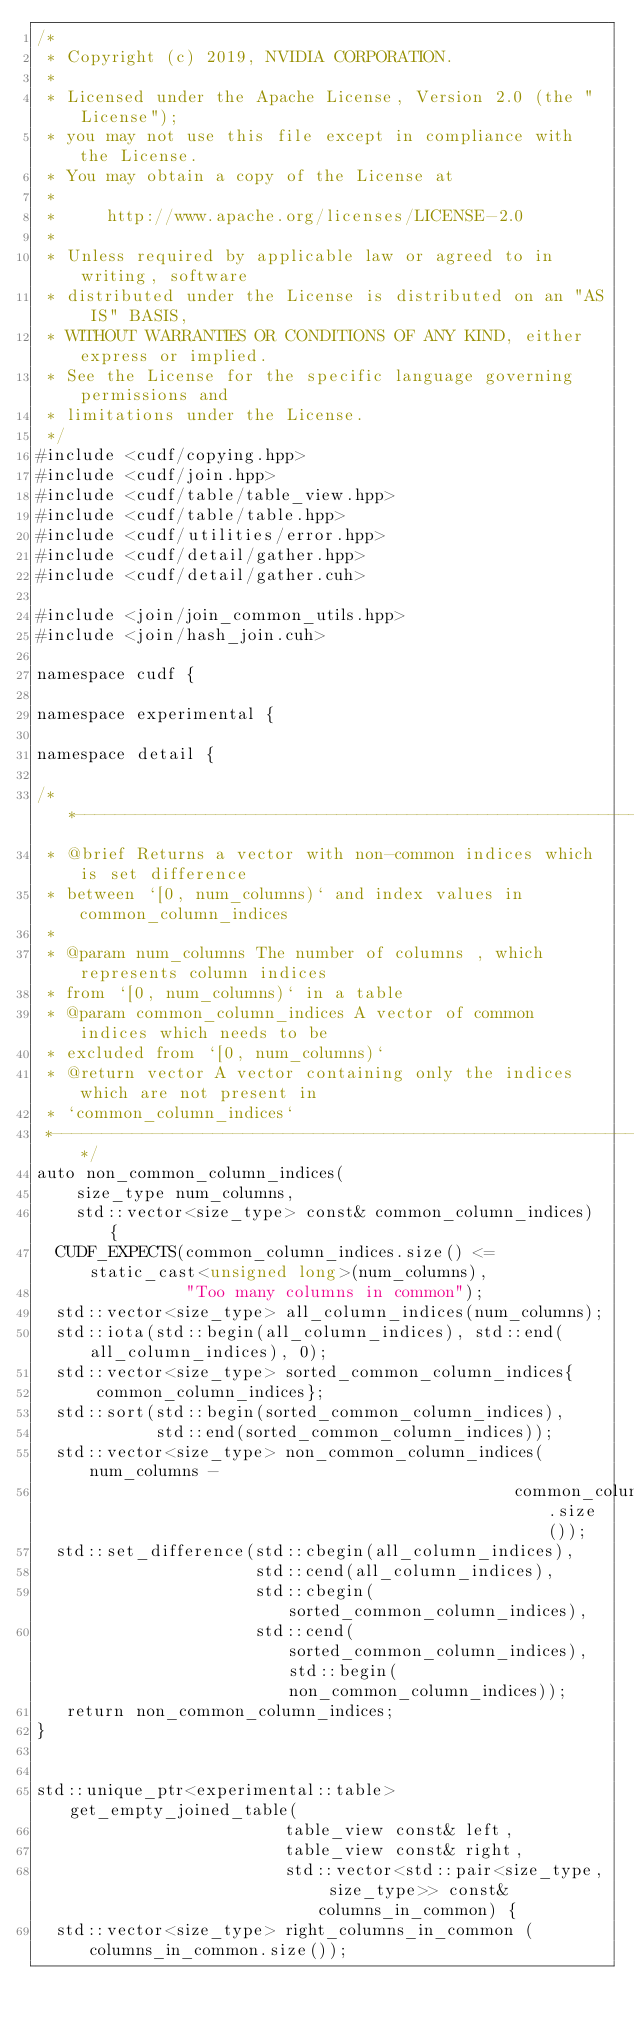<code> <loc_0><loc_0><loc_500><loc_500><_Cuda_>/*
 * Copyright (c) 2019, NVIDIA CORPORATION.
 *
 * Licensed under the Apache License, Version 2.0 (the "License");
 * you may not use this file except in compliance with the License.
 * You may obtain a copy of the License at
 *
 *     http://www.apache.org/licenses/LICENSE-2.0
 *
 * Unless required by applicable law or agreed to in writing, software
 * distributed under the License is distributed on an "AS IS" BASIS,
 * WITHOUT WARRANTIES OR CONDITIONS OF ANY KIND, either express or implied.
 * See the License for the specific language governing permissions and
 * limitations under the License.
 */
#include <cudf/copying.hpp>
#include <cudf/join.hpp>
#include <cudf/table/table_view.hpp>
#include <cudf/table/table.hpp>
#include <cudf/utilities/error.hpp>
#include <cudf/detail/gather.hpp>
#include <cudf/detail/gather.cuh>

#include <join/join_common_utils.hpp>
#include <join/hash_join.cuh>

namespace cudf {

namespace experimental {

namespace detail {

/**---------------------------------------------------------------------------*
 * @brief Returns a vector with non-common indices which is set difference
 * between `[0, num_columns)` and index values in common_column_indices
 *
 * @param num_columns The number of columns , which represents column indices
 * from `[0, num_columns)` in a table
 * @param common_column_indices A vector of common indices which needs to be
 * excluded from `[0, num_columns)`
 * @return vector A vector containing only the indices which are not present in
 * `common_column_indices`
 *---------------------------------------------------------------------------**/
auto non_common_column_indices(
    size_type num_columns,
    std::vector<size_type> const& common_column_indices) {
  CUDF_EXPECTS(common_column_indices.size() <= static_cast<unsigned long>(num_columns),
               "Too many columns in common");
  std::vector<size_type> all_column_indices(num_columns);
  std::iota(std::begin(all_column_indices), std::end(all_column_indices), 0);
  std::vector<size_type> sorted_common_column_indices{
      common_column_indices};
  std::sort(std::begin(sorted_common_column_indices),
            std::end(sorted_common_column_indices));
  std::vector<size_type> non_common_column_indices(num_columns -
                                                common_column_indices.size());
  std::set_difference(std::cbegin(all_column_indices),
                      std::cend(all_column_indices),
                      std::cbegin(sorted_common_column_indices),
                      std::cend(sorted_common_column_indices), std::begin(non_common_column_indices));
   return non_common_column_indices;
}


std::unique_ptr<experimental::table> get_empty_joined_table(
                         table_view const& left,
                         table_view const& right,
                         std::vector<std::pair<size_type, size_type>> const& columns_in_common) {
  std::vector<size_type> right_columns_in_common (columns_in_common.size());</code> 